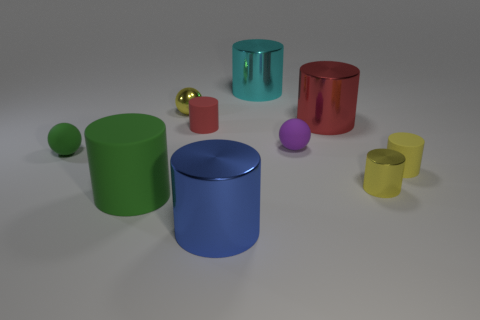Are there any blue cylinders made of the same material as the yellow sphere?
Your response must be concise. Yes. There is another matte object that is the same color as the large rubber thing; what size is it?
Provide a succinct answer. Small. What is the tiny cylinder that is behind the purple thing behind the tiny green rubber object made of?
Offer a terse response. Rubber. What number of other shiny spheres are the same color as the tiny metallic ball?
Provide a short and direct response. 0. What is the size of the yellow thing that is the same material as the yellow ball?
Your answer should be compact. Small. What is the shape of the tiny thing on the left side of the big rubber cylinder?
Provide a short and direct response. Sphere. What size is the other matte object that is the same shape as the small purple thing?
Make the answer very short. Small. There is a small object in front of the cylinder that is to the right of the small shiny cylinder; what number of shiny objects are in front of it?
Give a very brief answer. 1. Are there an equal number of small yellow spheres that are on the right side of the tiny yellow sphere and blue spheres?
Provide a short and direct response. Yes. How many cylinders are large metal objects or cyan objects?
Make the answer very short. 3. 